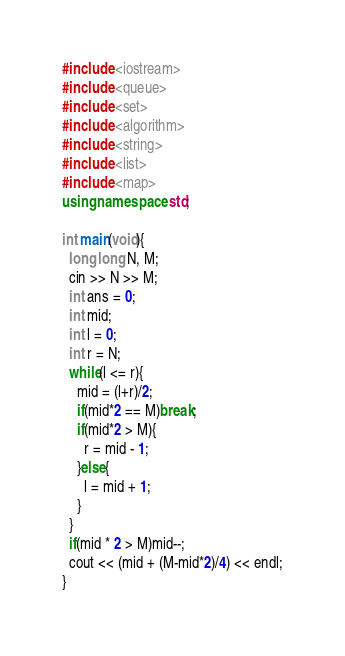<code> <loc_0><loc_0><loc_500><loc_500><_C++_>#include <iostream>
#include <queue>
#include <set>
#include <algorithm>
#include <string>
#include <list>
#include <map>
using namespace std;

int main(void){
  long long N, M;
  cin >> N >> M;
  int ans = 0;
  int mid;
  int l = 0;
  int r = N;
  while(l <= r){
    mid = (l+r)/2;
    if(mid*2 == M)break;
    if(mid*2 > M){
      r = mid - 1;
    }else{
      l = mid + 1;
    }
  }
  if(mid * 2 > M)mid--;
  cout << (mid + (M-mid*2)/4) << endl;
}
</code> 